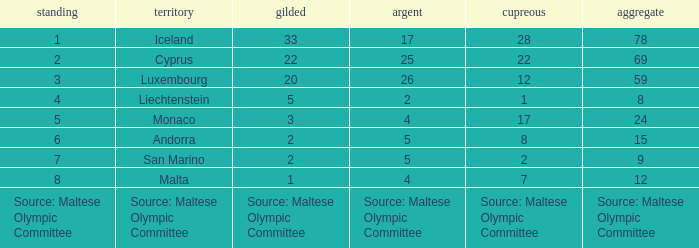Could you parse the entire table? {'header': ['standing', 'territory', 'gilded', 'argent', 'cupreous', 'aggregate'], 'rows': [['1', 'Iceland', '33', '17', '28', '78'], ['2', 'Cyprus', '22', '25', '22', '69'], ['3', 'Luxembourg', '20', '26', '12', '59'], ['4', 'Liechtenstein', '5', '2', '1', '8'], ['5', 'Monaco', '3', '4', '17', '24'], ['6', 'Andorra', '2', '5', '8', '15'], ['7', 'San Marino', '2', '5', '2', '9'], ['8', 'Malta', '1', '4', '7', '12'], ['Source: Maltese Olympic Committee', 'Source: Maltese Olympic Committee', 'Source: Maltese Olympic Committee', 'Source: Maltese Olympic Committee', 'Source: Maltese Olympic Committee', 'Source: Maltese Olympic Committee']]} What rank is the nation with 2 silver medals? 4.0. 